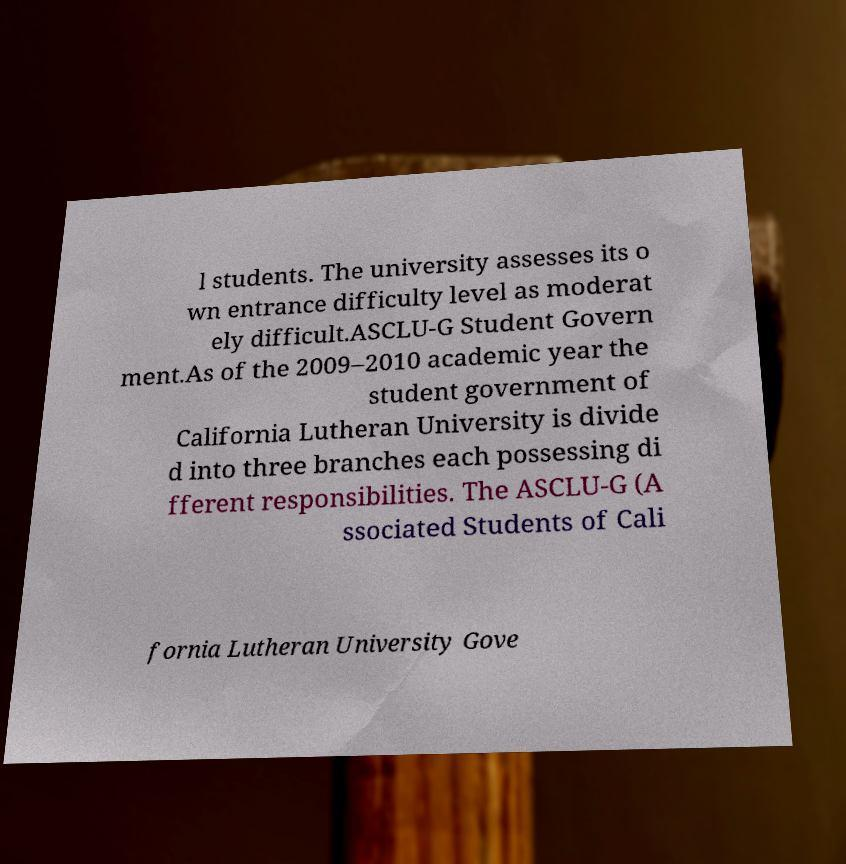Can you read and provide the text displayed in the image?This photo seems to have some interesting text. Can you extract and type it out for me? l students. The university assesses its o wn entrance difficulty level as moderat ely difficult.ASCLU-G Student Govern ment.As of the 2009–2010 academic year the student government of California Lutheran University is divide d into three branches each possessing di fferent responsibilities. The ASCLU-G (A ssociated Students of Cali fornia Lutheran University Gove 